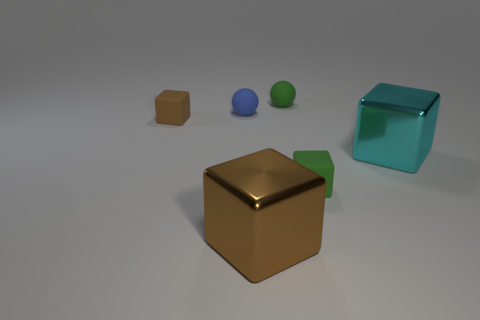How many things are either big shiny cubes that are on the left side of the large cyan object or matte balls?
Provide a short and direct response. 3. There is a small block right of the green matte sphere; what number of large blocks are behind it?
Your answer should be compact. 1. What is the size of the brown object that is in front of the tiny green object that is in front of the green thing that is behind the green matte block?
Make the answer very short. Large. There is a brown matte thing that is the same shape as the cyan metal thing; what size is it?
Make the answer very short. Small. How many objects are either tiny rubber spheres that are to the right of the large brown shiny block or objects that are behind the large cyan shiny thing?
Ensure brevity in your answer.  3. There is a brown thing that is in front of the tiny matte cube to the left of the green cube; what is its shape?
Your response must be concise. Cube. What number of things are big cyan blocks or big brown blocks?
Make the answer very short. 2. Are there any other cubes of the same size as the cyan cube?
Your response must be concise. Yes. The small blue object has what shape?
Ensure brevity in your answer.  Sphere. Are there more objects behind the big cyan cube than tiny blue spheres that are right of the small brown matte block?
Offer a terse response. Yes. 